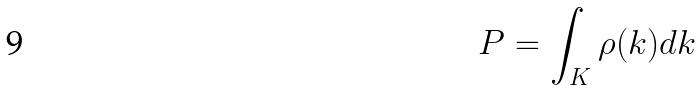Convert formula to latex. <formula><loc_0><loc_0><loc_500><loc_500>P = \int _ { K } \rho ( k ) d k</formula> 